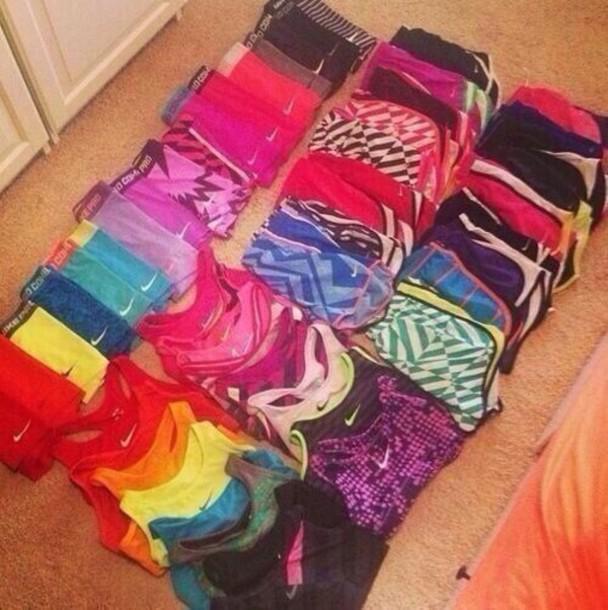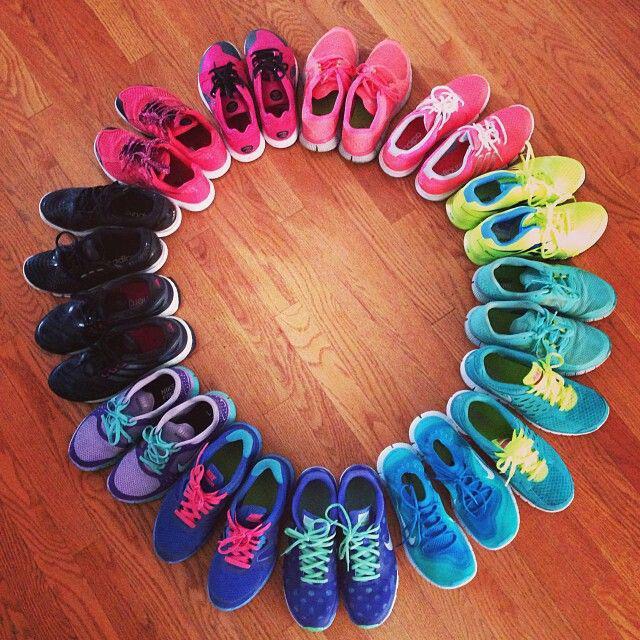The first image is the image on the left, the second image is the image on the right. Considering the images on both sides, is "One image contains at least 6 pairs of shoes." valid? Answer yes or no. Yes. The first image is the image on the left, the second image is the image on the right. Evaluate the accuracy of this statement regarding the images: "Each image includes exactly one pair of sneakers.". Is it true? Answer yes or no. No. 